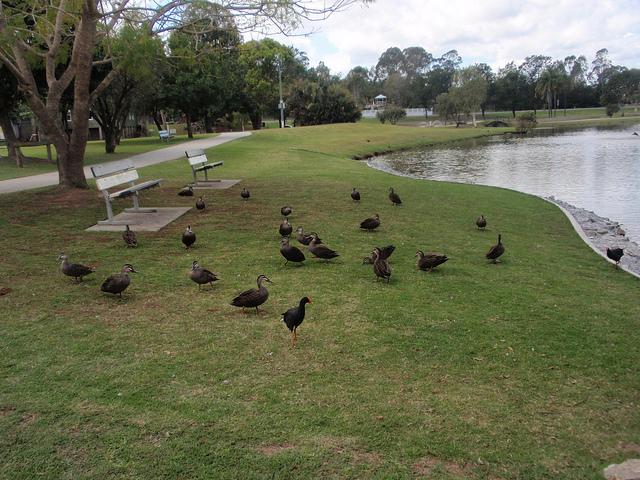How many benches?
Give a very brief answer. 2. How many birds are on the ground?
Short answer required. 23. What kind of animals are there?
Concise answer only. Ducks. How is the fowl in the front center different from those behind it?
Write a very short answer. Color. 